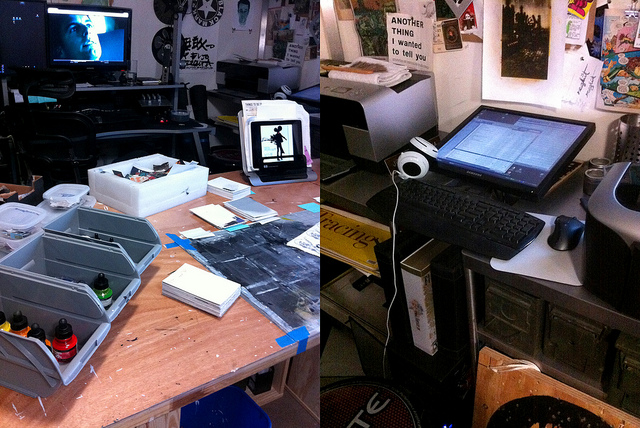Please transcribe the text information in this image. AHOTHER THING I wanted tell yes TE acing 